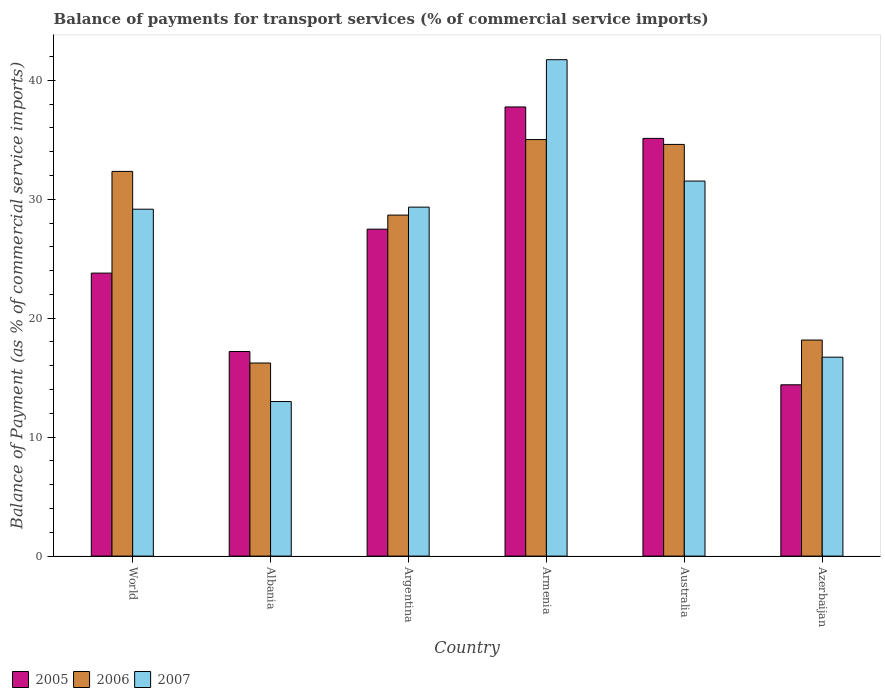How many different coloured bars are there?
Give a very brief answer. 3. Are the number of bars per tick equal to the number of legend labels?
Ensure brevity in your answer.  Yes. Are the number of bars on each tick of the X-axis equal?
Provide a short and direct response. Yes. What is the label of the 2nd group of bars from the left?
Your answer should be very brief. Albania. In how many cases, is the number of bars for a given country not equal to the number of legend labels?
Ensure brevity in your answer.  0. What is the balance of payments for transport services in 2007 in Australia?
Give a very brief answer. 31.53. Across all countries, what is the maximum balance of payments for transport services in 2007?
Ensure brevity in your answer.  41.73. Across all countries, what is the minimum balance of payments for transport services in 2005?
Offer a very short reply. 14.4. In which country was the balance of payments for transport services in 2007 maximum?
Offer a very short reply. Armenia. In which country was the balance of payments for transport services in 2007 minimum?
Provide a succinct answer. Albania. What is the total balance of payments for transport services in 2005 in the graph?
Offer a very short reply. 155.74. What is the difference between the balance of payments for transport services in 2006 in Armenia and that in World?
Provide a short and direct response. 2.67. What is the difference between the balance of payments for transport services in 2006 in World and the balance of payments for transport services in 2007 in Albania?
Provide a succinct answer. 19.35. What is the average balance of payments for transport services in 2006 per country?
Provide a short and direct response. 27.5. What is the difference between the balance of payments for transport services of/in 2006 and balance of payments for transport services of/in 2005 in Azerbaijan?
Your answer should be very brief. 3.76. In how many countries, is the balance of payments for transport services in 2007 greater than 8 %?
Your response must be concise. 6. What is the ratio of the balance of payments for transport services in 2006 in Albania to that in World?
Offer a terse response. 0.5. Is the balance of payments for transport services in 2006 in Argentina less than that in Azerbaijan?
Give a very brief answer. No. What is the difference between the highest and the second highest balance of payments for transport services in 2005?
Offer a terse response. -7.63. What is the difference between the highest and the lowest balance of payments for transport services in 2005?
Provide a succinct answer. 23.36. In how many countries, is the balance of payments for transport services in 2007 greater than the average balance of payments for transport services in 2007 taken over all countries?
Your answer should be compact. 4. What does the 2nd bar from the right in Albania represents?
Offer a very short reply. 2006. Is it the case that in every country, the sum of the balance of payments for transport services in 2006 and balance of payments for transport services in 2007 is greater than the balance of payments for transport services in 2005?
Provide a succinct answer. Yes. How many bars are there?
Your answer should be very brief. 18. Are all the bars in the graph horizontal?
Provide a succinct answer. No. Where does the legend appear in the graph?
Give a very brief answer. Bottom left. What is the title of the graph?
Your answer should be compact. Balance of payments for transport services (% of commercial service imports). What is the label or title of the Y-axis?
Keep it short and to the point. Balance of Payment (as % of commercial service imports). What is the Balance of Payment (as % of commercial service imports) in 2005 in World?
Give a very brief answer. 23.79. What is the Balance of Payment (as % of commercial service imports) of 2006 in World?
Your answer should be very brief. 32.34. What is the Balance of Payment (as % of commercial service imports) in 2007 in World?
Offer a very short reply. 29.16. What is the Balance of Payment (as % of commercial service imports) of 2005 in Albania?
Provide a short and direct response. 17.2. What is the Balance of Payment (as % of commercial service imports) of 2006 in Albania?
Ensure brevity in your answer.  16.23. What is the Balance of Payment (as % of commercial service imports) in 2007 in Albania?
Provide a succinct answer. 12.99. What is the Balance of Payment (as % of commercial service imports) in 2005 in Argentina?
Your answer should be compact. 27.48. What is the Balance of Payment (as % of commercial service imports) in 2006 in Argentina?
Make the answer very short. 28.67. What is the Balance of Payment (as % of commercial service imports) in 2007 in Argentina?
Make the answer very short. 29.34. What is the Balance of Payment (as % of commercial service imports) in 2005 in Armenia?
Offer a terse response. 37.76. What is the Balance of Payment (as % of commercial service imports) in 2006 in Armenia?
Offer a terse response. 35.01. What is the Balance of Payment (as % of commercial service imports) of 2007 in Armenia?
Your answer should be compact. 41.73. What is the Balance of Payment (as % of commercial service imports) of 2005 in Australia?
Keep it short and to the point. 35.11. What is the Balance of Payment (as % of commercial service imports) of 2006 in Australia?
Your answer should be compact. 34.61. What is the Balance of Payment (as % of commercial service imports) of 2007 in Australia?
Ensure brevity in your answer.  31.53. What is the Balance of Payment (as % of commercial service imports) in 2005 in Azerbaijan?
Your answer should be compact. 14.4. What is the Balance of Payment (as % of commercial service imports) of 2006 in Azerbaijan?
Provide a succinct answer. 18.16. What is the Balance of Payment (as % of commercial service imports) of 2007 in Azerbaijan?
Offer a terse response. 16.72. Across all countries, what is the maximum Balance of Payment (as % of commercial service imports) in 2005?
Give a very brief answer. 37.76. Across all countries, what is the maximum Balance of Payment (as % of commercial service imports) of 2006?
Provide a short and direct response. 35.01. Across all countries, what is the maximum Balance of Payment (as % of commercial service imports) of 2007?
Your response must be concise. 41.73. Across all countries, what is the minimum Balance of Payment (as % of commercial service imports) of 2005?
Ensure brevity in your answer.  14.4. Across all countries, what is the minimum Balance of Payment (as % of commercial service imports) in 2006?
Offer a very short reply. 16.23. Across all countries, what is the minimum Balance of Payment (as % of commercial service imports) of 2007?
Provide a short and direct response. 12.99. What is the total Balance of Payment (as % of commercial service imports) of 2005 in the graph?
Provide a succinct answer. 155.74. What is the total Balance of Payment (as % of commercial service imports) in 2006 in the graph?
Your answer should be very brief. 165.02. What is the total Balance of Payment (as % of commercial service imports) in 2007 in the graph?
Ensure brevity in your answer.  161.47. What is the difference between the Balance of Payment (as % of commercial service imports) in 2005 in World and that in Albania?
Make the answer very short. 6.59. What is the difference between the Balance of Payment (as % of commercial service imports) in 2006 in World and that in Albania?
Make the answer very short. 16.11. What is the difference between the Balance of Payment (as % of commercial service imports) in 2007 in World and that in Albania?
Offer a terse response. 16.17. What is the difference between the Balance of Payment (as % of commercial service imports) in 2005 in World and that in Argentina?
Ensure brevity in your answer.  -3.69. What is the difference between the Balance of Payment (as % of commercial service imports) of 2006 in World and that in Argentina?
Your response must be concise. 3.67. What is the difference between the Balance of Payment (as % of commercial service imports) in 2007 in World and that in Argentina?
Provide a short and direct response. -0.17. What is the difference between the Balance of Payment (as % of commercial service imports) in 2005 in World and that in Armenia?
Provide a short and direct response. -13.97. What is the difference between the Balance of Payment (as % of commercial service imports) of 2006 in World and that in Armenia?
Your answer should be compact. -2.67. What is the difference between the Balance of Payment (as % of commercial service imports) in 2007 in World and that in Armenia?
Make the answer very short. -12.57. What is the difference between the Balance of Payment (as % of commercial service imports) in 2005 in World and that in Australia?
Provide a short and direct response. -11.32. What is the difference between the Balance of Payment (as % of commercial service imports) of 2006 in World and that in Australia?
Your answer should be very brief. -2.27. What is the difference between the Balance of Payment (as % of commercial service imports) of 2007 in World and that in Australia?
Offer a very short reply. -2.37. What is the difference between the Balance of Payment (as % of commercial service imports) in 2005 in World and that in Azerbaijan?
Your answer should be very brief. 9.39. What is the difference between the Balance of Payment (as % of commercial service imports) in 2006 in World and that in Azerbaijan?
Offer a very short reply. 14.18. What is the difference between the Balance of Payment (as % of commercial service imports) of 2007 in World and that in Azerbaijan?
Make the answer very short. 12.44. What is the difference between the Balance of Payment (as % of commercial service imports) in 2005 in Albania and that in Argentina?
Make the answer very short. -10.29. What is the difference between the Balance of Payment (as % of commercial service imports) in 2006 in Albania and that in Argentina?
Provide a succinct answer. -12.43. What is the difference between the Balance of Payment (as % of commercial service imports) of 2007 in Albania and that in Argentina?
Keep it short and to the point. -16.34. What is the difference between the Balance of Payment (as % of commercial service imports) of 2005 in Albania and that in Armenia?
Ensure brevity in your answer.  -20.56. What is the difference between the Balance of Payment (as % of commercial service imports) of 2006 in Albania and that in Armenia?
Your response must be concise. -18.78. What is the difference between the Balance of Payment (as % of commercial service imports) of 2007 in Albania and that in Armenia?
Your response must be concise. -28.74. What is the difference between the Balance of Payment (as % of commercial service imports) in 2005 in Albania and that in Australia?
Make the answer very short. -17.92. What is the difference between the Balance of Payment (as % of commercial service imports) of 2006 in Albania and that in Australia?
Your answer should be compact. -18.38. What is the difference between the Balance of Payment (as % of commercial service imports) in 2007 in Albania and that in Australia?
Your response must be concise. -18.53. What is the difference between the Balance of Payment (as % of commercial service imports) of 2005 in Albania and that in Azerbaijan?
Ensure brevity in your answer.  2.8. What is the difference between the Balance of Payment (as % of commercial service imports) in 2006 in Albania and that in Azerbaijan?
Ensure brevity in your answer.  -1.93. What is the difference between the Balance of Payment (as % of commercial service imports) in 2007 in Albania and that in Azerbaijan?
Keep it short and to the point. -3.73. What is the difference between the Balance of Payment (as % of commercial service imports) in 2005 in Argentina and that in Armenia?
Provide a succinct answer. -10.27. What is the difference between the Balance of Payment (as % of commercial service imports) of 2006 in Argentina and that in Armenia?
Give a very brief answer. -6.35. What is the difference between the Balance of Payment (as % of commercial service imports) in 2007 in Argentina and that in Armenia?
Ensure brevity in your answer.  -12.39. What is the difference between the Balance of Payment (as % of commercial service imports) of 2005 in Argentina and that in Australia?
Give a very brief answer. -7.63. What is the difference between the Balance of Payment (as % of commercial service imports) of 2006 in Argentina and that in Australia?
Your response must be concise. -5.94. What is the difference between the Balance of Payment (as % of commercial service imports) in 2007 in Argentina and that in Australia?
Your answer should be very brief. -2.19. What is the difference between the Balance of Payment (as % of commercial service imports) of 2005 in Argentina and that in Azerbaijan?
Offer a terse response. 13.08. What is the difference between the Balance of Payment (as % of commercial service imports) of 2006 in Argentina and that in Azerbaijan?
Give a very brief answer. 10.5. What is the difference between the Balance of Payment (as % of commercial service imports) of 2007 in Argentina and that in Azerbaijan?
Offer a terse response. 12.61. What is the difference between the Balance of Payment (as % of commercial service imports) in 2005 in Armenia and that in Australia?
Your answer should be compact. 2.64. What is the difference between the Balance of Payment (as % of commercial service imports) of 2006 in Armenia and that in Australia?
Your answer should be compact. 0.41. What is the difference between the Balance of Payment (as % of commercial service imports) in 2007 in Armenia and that in Australia?
Offer a very short reply. 10.2. What is the difference between the Balance of Payment (as % of commercial service imports) of 2005 in Armenia and that in Azerbaijan?
Ensure brevity in your answer.  23.36. What is the difference between the Balance of Payment (as % of commercial service imports) in 2006 in Armenia and that in Azerbaijan?
Your answer should be very brief. 16.85. What is the difference between the Balance of Payment (as % of commercial service imports) in 2007 in Armenia and that in Azerbaijan?
Ensure brevity in your answer.  25.01. What is the difference between the Balance of Payment (as % of commercial service imports) of 2005 in Australia and that in Azerbaijan?
Offer a very short reply. 20.71. What is the difference between the Balance of Payment (as % of commercial service imports) of 2006 in Australia and that in Azerbaijan?
Your answer should be very brief. 16.44. What is the difference between the Balance of Payment (as % of commercial service imports) of 2007 in Australia and that in Azerbaijan?
Provide a short and direct response. 14.81. What is the difference between the Balance of Payment (as % of commercial service imports) in 2005 in World and the Balance of Payment (as % of commercial service imports) in 2006 in Albania?
Ensure brevity in your answer.  7.56. What is the difference between the Balance of Payment (as % of commercial service imports) in 2005 in World and the Balance of Payment (as % of commercial service imports) in 2007 in Albania?
Give a very brief answer. 10.8. What is the difference between the Balance of Payment (as % of commercial service imports) in 2006 in World and the Balance of Payment (as % of commercial service imports) in 2007 in Albania?
Your answer should be very brief. 19.35. What is the difference between the Balance of Payment (as % of commercial service imports) of 2005 in World and the Balance of Payment (as % of commercial service imports) of 2006 in Argentina?
Your response must be concise. -4.88. What is the difference between the Balance of Payment (as % of commercial service imports) in 2005 in World and the Balance of Payment (as % of commercial service imports) in 2007 in Argentina?
Ensure brevity in your answer.  -5.55. What is the difference between the Balance of Payment (as % of commercial service imports) in 2006 in World and the Balance of Payment (as % of commercial service imports) in 2007 in Argentina?
Offer a very short reply. 3. What is the difference between the Balance of Payment (as % of commercial service imports) in 2005 in World and the Balance of Payment (as % of commercial service imports) in 2006 in Armenia?
Your response must be concise. -11.22. What is the difference between the Balance of Payment (as % of commercial service imports) of 2005 in World and the Balance of Payment (as % of commercial service imports) of 2007 in Armenia?
Offer a terse response. -17.94. What is the difference between the Balance of Payment (as % of commercial service imports) in 2006 in World and the Balance of Payment (as % of commercial service imports) in 2007 in Armenia?
Make the answer very short. -9.39. What is the difference between the Balance of Payment (as % of commercial service imports) in 2005 in World and the Balance of Payment (as % of commercial service imports) in 2006 in Australia?
Ensure brevity in your answer.  -10.82. What is the difference between the Balance of Payment (as % of commercial service imports) in 2005 in World and the Balance of Payment (as % of commercial service imports) in 2007 in Australia?
Provide a short and direct response. -7.74. What is the difference between the Balance of Payment (as % of commercial service imports) of 2006 in World and the Balance of Payment (as % of commercial service imports) of 2007 in Australia?
Keep it short and to the point. 0.81. What is the difference between the Balance of Payment (as % of commercial service imports) of 2005 in World and the Balance of Payment (as % of commercial service imports) of 2006 in Azerbaijan?
Offer a very short reply. 5.63. What is the difference between the Balance of Payment (as % of commercial service imports) in 2005 in World and the Balance of Payment (as % of commercial service imports) in 2007 in Azerbaijan?
Give a very brief answer. 7.07. What is the difference between the Balance of Payment (as % of commercial service imports) in 2006 in World and the Balance of Payment (as % of commercial service imports) in 2007 in Azerbaijan?
Offer a terse response. 15.62. What is the difference between the Balance of Payment (as % of commercial service imports) in 2005 in Albania and the Balance of Payment (as % of commercial service imports) in 2006 in Argentina?
Offer a very short reply. -11.47. What is the difference between the Balance of Payment (as % of commercial service imports) in 2005 in Albania and the Balance of Payment (as % of commercial service imports) in 2007 in Argentina?
Offer a very short reply. -12.14. What is the difference between the Balance of Payment (as % of commercial service imports) of 2006 in Albania and the Balance of Payment (as % of commercial service imports) of 2007 in Argentina?
Your answer should be very brief. -13.1. What is the difference between the Balance of Payment (as % of commercial service imports) of 2005 in Albania and the Balance of Payment (as % of commercial service imports) of 2006 in Armenia?
Keep it short and to the point. -17.82. What is the difference between the Balance of Payment (as % of commercial service imports) in 2005 in Albania and the Balance of Payment (as % of commercial service imports) in 2007 in Armenia?
Offer a very short reply. -24.53. What is the difference between the Balance of Payment (as % of commercial service imports) in 2006 in Albania and the Balance of Payment (as % of commercial service imports) in 2007 in Armenia?
Make the answer very short. -25.5. What is the difference between the Balance of Payment (as % of commercial service imports) of 2005 in Albania and the Balance of Payment (as % of commercial service imports) of 2006 in Australia?
Keep it short and to the point. -17.41. What is the difference between the Balance of Payment (as % of commercial service imports) in 2005 in Albania and the Balance of Payment (as % of commercial service imports) in 2007 in Australia?
Provide a short and direct response. -14.33. What is the difference between the Balance of Payment (as % of commercial service imports) of 2006 in Albania and the Balance of Payment (as % of commercial service imports) of 2007 in Australia?
Provide a short and direct response. -15.3. What is the difference between the Balance of Payment (as % of commercial service imports) of 2005 in Albania and the Balance of Payment (as % of commercial service imports) of 2006 in Azerbaijan?
Your answer should be very brief. -0.97. What is the difference between the Balance of Payment (as % of commercial service imports) of 2005 in Albania and the Balance of Payment (as % of commercial service imports) of 2007 in Azerbaijan?
Your answer should be compact. 0.48. What is the difference between the Balance of Payment (as % of commercial service imports) of 2006 in Albania and the Balance of Payment (as % of commercial service imports) of 2007 in Azerbaijan?
Offer a very short reply. -0.49. What is the difference between the Balance of Payment (as % of commercial service imports) in 2005 in Argentina and the Balance of Payment (as % of commercial service imports) in 2006 in Armenia?
Your answer should be compact. -7.53. What is the difference between the Balance of Payment (as % of commercial service imports) in 2005 in Argentina and the Balance of Payment (as % of commercial service imports) in 2007 in Armenia?
Offer a terse response. -14.25. What is the difference between the Balance of Payment (as % of commercial service imports) in 2006 in Argentina and the Balance of Payment (as % of commercial service imports) in 2007 in Armenia?
Your answer should be compact. -13.06. What is the difference between the Balance of Payment (as % of commercial service imports) in 2005 in Argentina and the Balance of Payment (as % of commercial service imports) in 2006 in Australia?
Make the answer very short. -7.12. What is the difference between the Balance of Payment (as % of commercial service imports) of 2005 in Argentina and the Balance of Payment (as % of commercial service imports) of 2007 in Australia?
Ensure brevity in your answer.  -4.04. What is the difference between the Balance of Payment (as % of commercial service imports) of 2006 in Argentina and the Balance of Payment (as % of commercial service imports) of 2007 in Australia?
Your answer should be compact. -2.86. What is the difference between the Balance of Payment (as % of commercial service imports) in 2005 in Argentina and the Balance of Payment (as % of commercial service imports) in 2006 in Azerbaijan?
Give a very brief answer. 9.32. What is the difference between the Balance of Payment (as % of commercial service imports) in 2005 in Argentina and the Balance of Payment (as % of commercial service imports) in 2007 in Azerbaijan?
Provide a short and direct response. 10.76. What is the difference between the Balance of Payment (as % of commercial service imports) in 2006 in Argentina and the Balance of Payment (as % of commercial service imports) in 2007 in Azerbaijan?
Your answer should be compact. 11.95. What is the difference between the Balance of Payment (as % of commercial service imports) in 2005 in Armenia and the Balance of Payment (as % of commercial service imports) in 2006 in Australia?
Give a very brief answer. 3.15. What is the difference between the Balance of Payment (as % of commercial service imports) in 2005 in Armenia and the Balance of Payment (as % of commercial service imports) in 2007 in Australia?
Give a very brief answer. 6.23. What is the difference between the Balance of Payment (as % of commercial service imports) of 2006 in Armenia and the Balance of Payment (as % of commercial service imports) of 2007 in Australia?
Offer a terse response. 3.49. What is the difference between the Balance of Payment (as % of commercial service imports) in 2005 in Armenia and the Balance of Payment (as % of commercial service imports) in 2006 in Azerbaijan?
Give a very brief answer. 19.59. What is the difference between the Balance of Payment (as % of commercial service imports) of 2005 in Armenia and the Balance of Payment (as % of commercial service imports) of 2007 in Azerbaijan?
Offer a terse response. 21.04. What is the difference between the Balance of Payment (as % of commercial service imports) in 2006 in Armenia and the Balance of Payment (as % of commercial service imports) in 2007 in Azerbaijan?
Your answer should be compact. 18.29. What is the difference between the Balance of Payment (as % of commercial service imports) in 2005 in Australia and the Balance of Payment (as % of commercial service imports) in 2006 in Azerbaijan?
Make the answer very short. 16.95. What is the difference between the Balance of Payment (as % of commercial service imports) in 2005 in Australia and the Balance of Payment (as % of commercial service imports) in 2007 in Azerbaijan?
Offer a very short reply. 18.39. What is the difference between the Balance of Payment (as % of commercial service imports) of 2006 in Australia and the Balance of Payment (as % of commercial service imports) of 2007 in Azerbaijan?
Provide a short and direct response. 17.89. What is the average Balance of Payment (as % of commercial service imports) in 2005 per country?
Give a very brief answer. 25.96. What is the average Balance of Payment (as % of commercial service imports) of 2006 per country?
Your response must be concise. 27.5. What is the average Balance of Payment (as % of commercial service imports) of 2007 per country?
Your response must be concise. 26.91. What is the difference between the Balance of Payment (as % of commercial service imports) of 2005 and Balance of Payment (as % of commercial service imports) of 2006 in World?
Ensure brevity in your answer.  -8.55. What is the difference between the Balance of Payment (as % of commercial service imports) of 2005 and Balance of Payment (as % of commercial service imports) of 2007 in World?
Provide a short and direct response. -5.37. What is the difference between the Balance of Payment (as % of commercial service imports) in 2006 and Balance of Payment (as % of commercial service imports) in 2007 in World?
Your answer should be very brief. 3.18. What is the difference between the Balance of Payment (as % of commercial service imports) of 2005 and Balance of Payment (as % of commercial service imports) of 2006 in Albania?
Your response must be concise. 0.97. What is the difference between the Balance of Payment (as % of commercial service imports) in 2005 and Balance of Payment (as % of commercial service imports) in 2007 in Albania?
Provide a succinct answer. 4.2. What is the difference between the Balance of Payment (as % of commercial service imports) in 2006 and Balance of Payment (as % of commercial service imports) in 2007 in Albania?
Your answer should be compact. 3.24. What is the difference between the Balance of Payment (as % of commercial service imports) of 2005 and Balance of Payment (as % of commercial service imports) of 2006 in Argentina?
Give a very brief answer. -1.18. What is the difference between the Balance of Payment (as % of commercial service imports) of 2005 and Balance of Payment (as % of commercial service imports) of 2007 in Argentina?
Your response must be concise. -1.85. What is the difference between the Balance of Payment (as % of commercial service imports) in 2006 and Balance of Payment (as % of commercial service imports) in 2007 in Argentina?
Provide a short and direct response. -0.67. What is the difference between the Balance of Payment (as % of commercial service imports) in 2005 and Balance of Payment (as % of commercial service imports) in 2006 in Armenia?
Your answer should be compact. 2.74. What is the difference between the Balance of Payment (as % of commercial service imports) in 2005 and Balance of Payment (as % of commercial service imports) in 2007 in Armenia?
Provide a short and direct response. -3.97. What is the difference between the Balance of Payment (as % of commercial service imports) of 2006 and Balance of Payment (as % of commercial service imports) of 2007 in Armenia?
Offer a very short reply. -6.72. What is the difference between the Balance of Payment (as % of commercial service imports) of 2005 and Balance of Payment (as % of commercial service imports) of 2006 in Australia?
Offer a very short reply. 0.51. What is the difference between the Balance of Payment (as % of commercial service imports) in 2005 and Balance of Payment (as % of commercial service imports) in 2007 in Australia?
Your answer should be very brief. 3.59. What is the difference between the Balance of Payment (as % of commercial service imports) in 2006 and Balance of Payment (as % of commercial service imports) in 2007 in Australia?
Keep it short and to the point. 3.08. What is the difference between the Balance of Payment (as % of commercial service imports) in 2005 and Balance of Payment (as % of commercial service imports) in 2006 in Azerbaijan?
Provide a succinct answer. -3.76. What is the difference between the Balance of Payment (as % of commercial service imports) of 2005 and Balance of Payment (as % of commercial service imports) of 2007 in Azerbaijan?
Offer a very short reply. -2.32. What is the difference between the Balance of Payment (as % of commercial service imports) of 2006 and Balance of Payment (as % of commercial service imports) of 2007 in Azerbaijan?
Offer a terse response. 1.44. What is the ratio of the Balance of Payment (as % of commercial service imports) in 2005 in World to that in Albania?
Your answer should be compact. 1.38. What is the ratio of the Balance of Payment (as % of commercial service imports) of 2006 in World to that in Albania?
Provide a succinct answer. 1.99. What is the ratio of the Balance of Payment (as % of commercial service imports) of 2007 in World to that in Albania?
Keep it short and to the point. 2.24. What is the ratio of the Balance of Payment (as % of commercial service imports) of 2005 in World to that in Argentina?
Your answer should be very brief. 0.87. What is the ratio of the Balance of Payment (as % of commercial service imports) of 2006 in World to that in Argentina?
Your answer should be very brief. 1.13. What is the ratio of the Balance of Payment (as % of commercial service imports) of 2007 in World to that in Argentina?
Provide a succinct answer. 0.99. What is the ratio of the Balance of Payment (as % of commercial service imports) of 2005 in World to that in Armenia?
Provide a short and direct response. 0.63. What is the ratio of the Balance of Payment (as % of commercial service imports) of 2006 in World to that in Armenia?
Your answer should be compact. 0.92. What is the ratio of the Balance of Payment (as % of commercial service imports) of 2007 in World to that in Armenia?
Your answer should be very brief. 0.7. What is the ratio of the Balance of Payment (as % of commercial service imports) of 2005 in World to that in Australia?
Provide a succinct answer. 0.68. What is the ratio of the Balance of Payment (as % of commercial service imports) of 2006 in World to that in Australia?
Provide a succinct answer. 0.93. What is the ratio of the Balance of Payment (as % of commercial service imports) of 2007 in World to that in Australia?
Provide a short and direct response. 0.93. What is the ratio of the Balance of Payment (as % of commercial service imports) of 2005 in World to that in Azerbaijan?
Give a very brief answer. 1.65. What is the ratio of the Balance of Payment (as % of commercial service imports) of 2006 in World to that in Azerbaijan?
Give a very brief answer. 1.78. What is the ratio of the Balance of Payment (as % of commercial service imports) in 2007 in World to that in Azerbaijan?
Provide a succinct answer. 1.74. What is the ratio of the Balance of Payment (as % of commercial service imports) in 2005 in Albania to that in Argentina?
Make the answer very short. 0.63. What is the ratio of the Balance of Payment (as % of commercial service imports) of 2006 in Albania to that in Argentina?
Make the answer very short. 0.57. What is the ratio of the Balance of Payment (as % of commercial service imports) in 2007 in Albania to that in Argentina?
Provide a succinct answer. 0.44. What is the ratio of the Balance of Payment (as % of commercial service imports) of 2005 in Albania to that in Armenia?
Give a very brief answer. 0.46. What is the ratio of the Balance of Payment (as % of commercial service imports) in 2006 in Albania to that in Armenia?
Give a very brief answer. 0.46. What is the ratio of the Balance of Payment (as % of commercial service imports) of 2007 in Albania to that in Armenia?
Offer a terse response. 0.31. What is the ratio of the Balance of Payment (as % of commercial service imports) of 2005 in Albania to that in Australia?
Provide a short and direct response. 0.49. What is the ratio of the Balance of Payment (as % of commercial service imports) in 2006 in Albania to that in Australia?
Provide a succinct answer. 0.47. What is the ratio of the Balance of Payment (as % of commercial service imports) in 2007 in Albania to that in Australia?
Provide a succinct answer. 0.41. What is the ratio of the Balance of Payment (as % of commercial service imports) in 2005 in Albania to that in Azerbaijan?
Offer a very short reply. 1.19. What is the ratio of the Balance of Payment (as % of commercial service imports) of 2006 in Albania to that in Azerbaijan?
Provide a succinct answer. 0.89. What is the ratio of the Balance of Payment (as % of commercial service imports) in 2007 in Albania to that in Azerbaijan?
Provide a succinct answer. 0.78. What is the ratio of the Balance of Payment (as % of commercial service imports) in 2005 in Argentina to that in Armenia?
Provide a succinct answer. 0.73. What is the ratio of the Balance of Payment (as % of commercial service imports) of 2006 in Argentina to that in Armenia?
Make the answer very short. 0.82. What is the ratio of the Balance of Payment (as % of commercial service imports) in 2007 in Argentina to that in Armenia?
Ensure brevity in your answer.  0.7. What is the ratio of the Balance of Payment (as % of commercial service imports) in 2005 in Argentina to that in Australia?
Provide a short and direct response. 0.78. What is the ratio of the Balance of Payment (as % of commercial service imports) of 2006 in Argentina to that in Australia?
Your answer should be very brief. 0.83. What is the ratio of the Balance of Payment (as % of commercial service imports) of 2007 in Argentina to that in Australia?
Ensure brevity in your answer.  0.93. What is the ratio of the Balance of Payment (as % of commercial service imports) in 2005 in Argentina to that in Azerbaijan?
Your answer should be compact. 1.91. What is the ratio of the Balance of Payment (as % of commercial service imports) of 2006 in Argentina to that in Azerbaijan?
Give a very brief answer. 1.58. What is the ratio of the Balance of Payment (as % of commercial service imports) in 2007 in Argentina to that in Azerbaijan?
Keep it short and to the point. 1.75. What is the ratio of the Balance of Payment (as % of commercial service imports) of 2005 in Armenia to that in Australia?
Provide a short and direct response. 1.08. What is the ratio of the Balance of Payment (as % of commercial service imports) of 2006 in Armenia to that in Australia?
Give a very brief answer. 1.01. What is the ratio of the Balance of Payment (as % of commercial service imports) of 2007 in Armenia to that in Australia?
Provide a short and direct response. 1.32. What is the ratio of the Balance of Payment (as % of commercial service imports) of 2005 in Armenia to that in Azerbaijan?
Keep it short and to the point. 2.62. What is the ratio of the Balance of Payment (as % of commercial service imports) of 2006 in Armenia to that in Azerbaijan?
Ensure brevity in your answer.  1.93. What is the ratio of the Balance of Payment (as % of commercial service imports) of 2007 in Armenia to that in Azerbaijan?
Your response must be concise. 2.5. What is the ratio of the Balance of Payment (as % of commercial service imports) of 2005 in Australia to that in Azerbaijan?
Make the answer very short. 2.44. What is the ratio of the Balance of Payment (as % of commercial service imports) in 2006 in Australia to that in Azerbaijan?
Provide a succinct answer. 1.91. What is the ratio of the Balance of Payment (as % of commercial service imports) of 2007 in Australia to that in Azerbaijan?
Keep it short and to the point. 1.89. What is the difference between the highest and the second highest Balance of Payment (as % of commercial service imports) of 2005?
Offer a very short reply. 2.64. What is the difference between the highest and the second highest Balance of Payment (as % of commercial service imports) of 2006?
Your response must be concise. 0.41. What is the difference between the highest and the second highest Balance of Payment (as % of commercial service imports) in 2007?
Provide a succinct answer. 10.2. What is the difference between the highest and the lowest Balance of Payment (as % of commercial service imports) in 2005?
Keep it short and to the point. 23.36. What is the difference between the highest and the lowest Balance of Payment (as % of commercial service imports) in 2006?
Ensure brevity in your answer.  18.78. What is the difference between the highest and the lowest Balance of Payment (as % of commercial service imports) in 2007?
Provide a short and direct response. 28.74. 